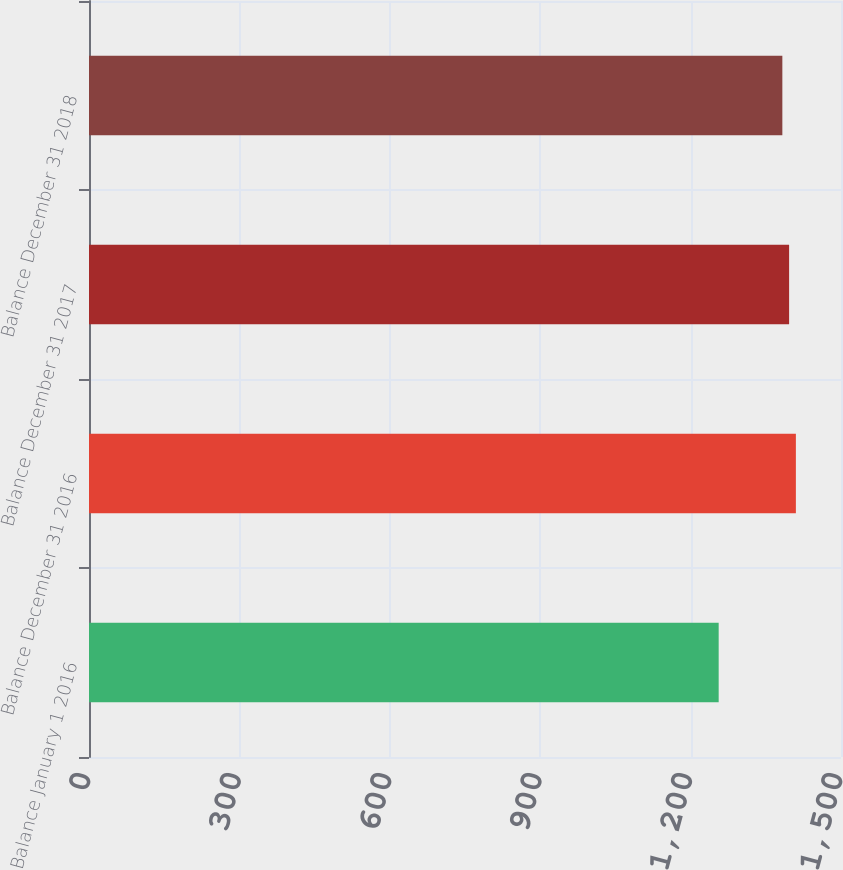Convert chart. <chart><loc_0><loc_0><loc_500><loc_500><bar_chart><fcel>Balance January 1 2016<fcel>Balance December 31 2016<fcel>Balance December 31 2017<fcel>Balance December 31 2018<nl><fcel>1256<fcel>1410<fcel>1396.5<fcel>1383<nl></chart> 